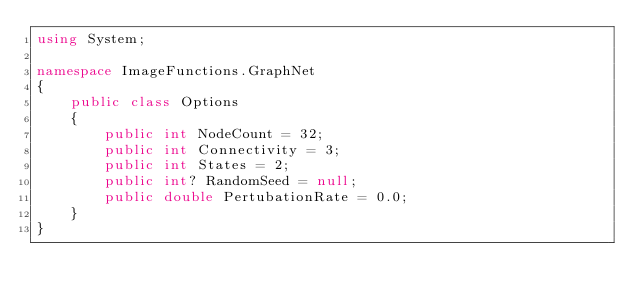Convert code to text. <code><loc_0><loc_0><loc_500><loc_500><_C#_>using System;

namespace ImageFunctions.GraphNet
{
	public class Options
	{
		public int NodeCount = 32;
		public int Connectivity = 3;
		public int States = 2;
		public int? RandomSeed = null;
		public double PertubationRate = 0.0;
	}
}</code> 